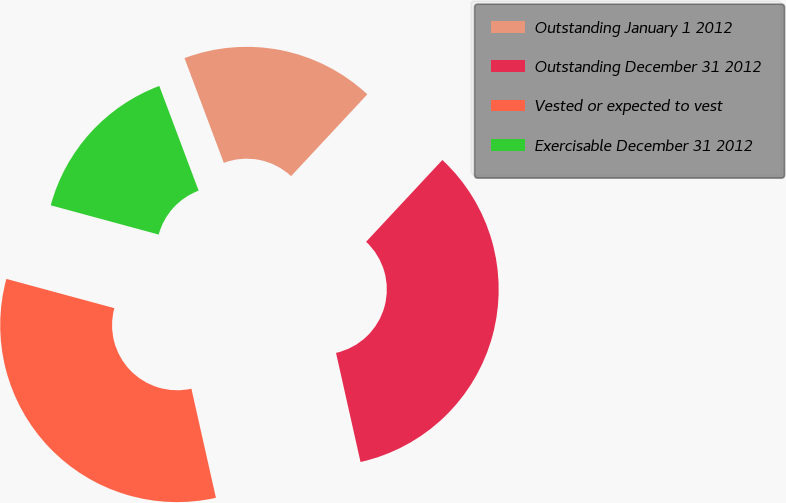Convert chart to OTSL. <chart><loc_0><loc_0><loc_500><loc_500><pie_chart><fcel>Outstanding January 1 2012<fcel>Outstanding December 31 2012<fcel>Vested or expected to vest<fcel>Exercisable December 31 2012<nl><fcel>17.66%<fcel>34.54%<fcel>32.73%<fcel>15.07%<nl></chart> 